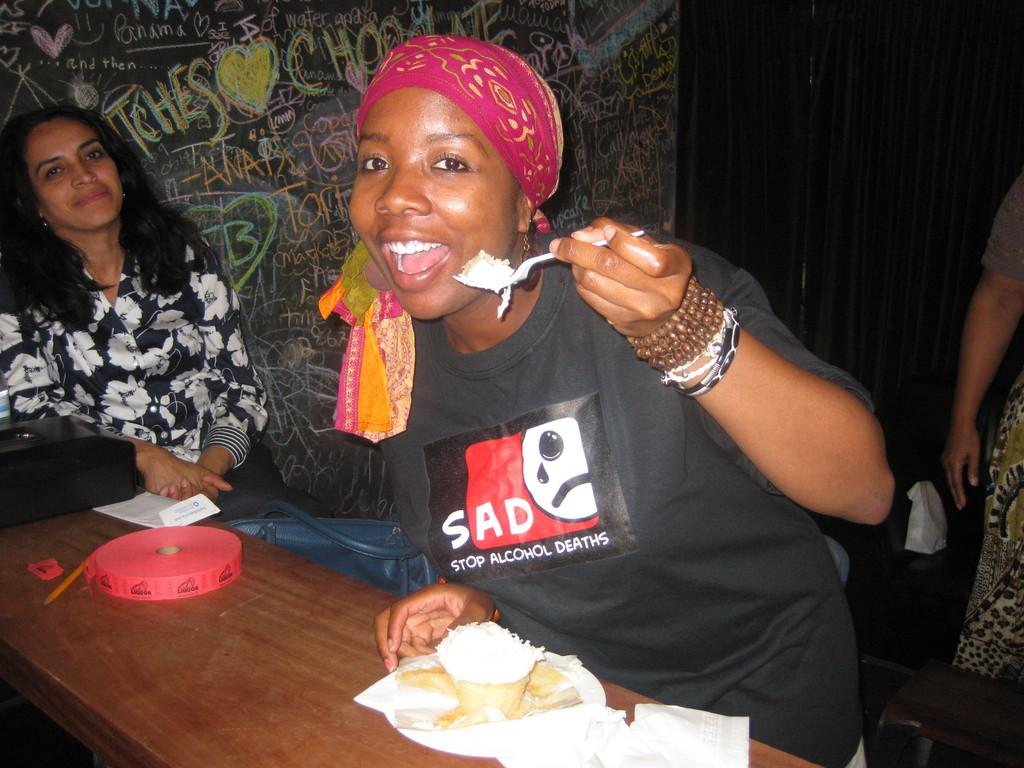How many people are in the image? There are people in the image, but the exact number is not specified. What is present on the table in the image? There is a table in the image, and on it, there is food, a ribbon, and other objects. What is the woman holding in the image? The woman is holding a fork in the image. What can be seen on the black wall in the image? There is something written on a black wall in the image. What type of curtain is visible in the image? There is a black curtain in the image. What type of quill is being used to write on the black wall in the image? There is no quill present in the image; the writing on the black wall is not specified as being done with a quill. 